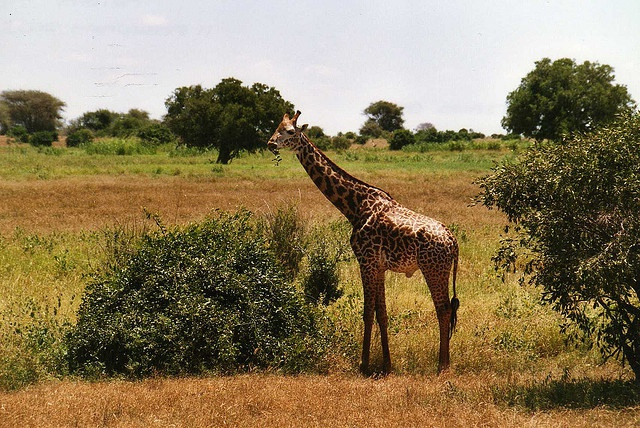Describe the objects in this image and their specific colors. I can see a giraffe in lightgray, black, maroon, and gray tones in this image. 